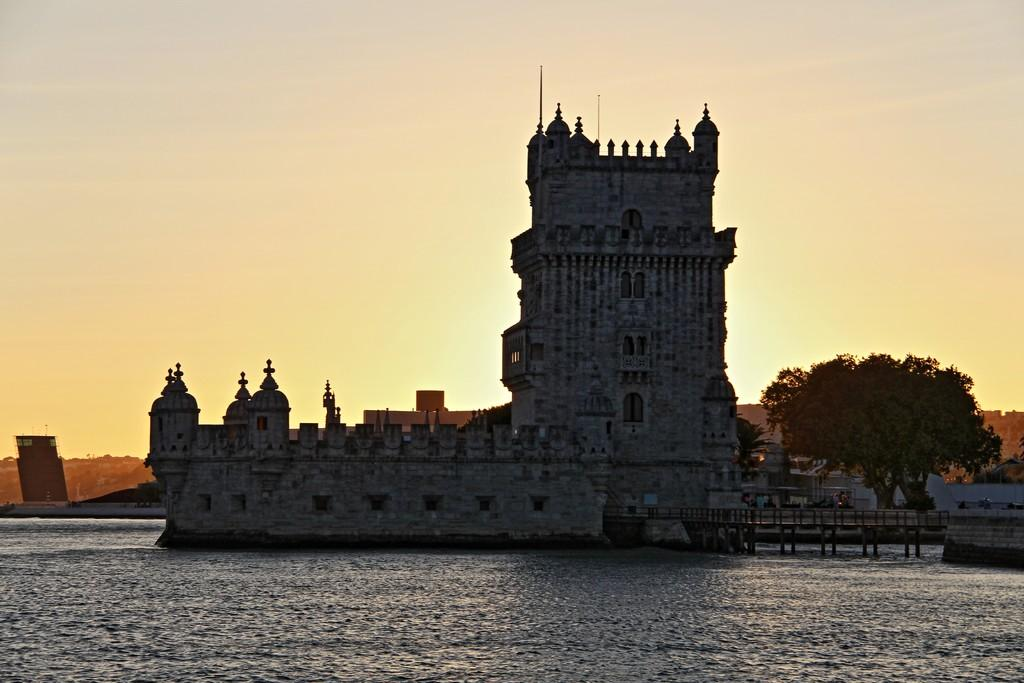What type of natural feature is present in the image? There is a lake in the image. What man-made structure can be seen in the image? There is a monument in the image. What type of vegetation is on the right side of the image? There is a tree on the right side of the image. What is visible at the top of the image? The sky is visible at the top of the image. How many plates are stacked on the tree in the image? There are no plates present in the image; it features a tree, a lake, and a monument. What grade is the monument in the image? The image does not provide information about the grade or any other rating of the monument. 